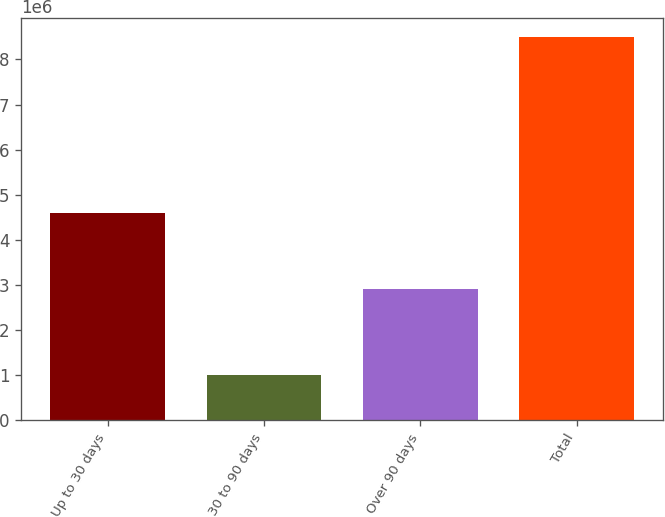Convert chart to OTSL. <chart><loc_0><loc_0><loc_500><loc_500><bar_chart><fcel>Up to 30 days<fcel>30 to 90 days<fcel>Over 90 days<fcel>Total<nl><fcel>4.58533e+06<fcel>1.00891e+06<fcel>2.9006e+06<fcel>8.49484e+06<nl></chart> 